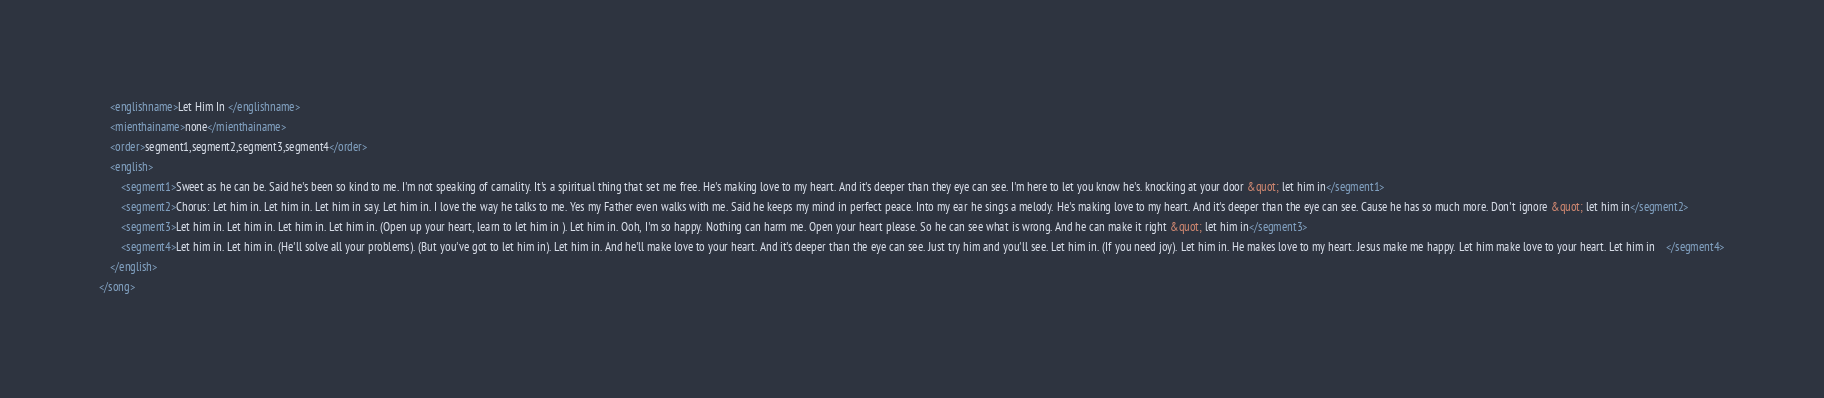<code> <loc_0><loc_0><loc_500><loc_500><_XML_>	<englishname>Let Him In </englishname>
	<mienthainame>none</mienthainame>
	<order>segment1,segment2,segment3,segment4</order>
	<english>
		<segment1>Sweet as he can be. Said he's been so kind to me. I'm not speaking of carnality. It's a spiritual thing that set me free. He's making love to my heart. And it's deeper than they eye can see. I'm here to let you know he's. knocking at your door &quot; let him in</segment1>
		<segment2>Chorus: Let him in. Let him in. Let him in say. Let him in. I love the way he talks to me. Yes my Father even walks with me. Said he keeps my mind in perfect peace. Into my ear he sings a melody. He's making love to my heart. And it's deeper than the eye can see. Cause he has so much more. Don't ignore &quot; let him in</segment2>
		<segment3>Let him in. Let him in. Let him in. Let him in. (Open up your heart, learn to let him in ). Let him in. Ooh, I'm so happy. Nothing can harm me. Open your heart please. So he can see what is wrong. And he can make it right &quot; let him in</segment3>
		<segment4>Let him in. Let him in. (He'll solve all your problems). (But you've got to let him in). Let him in. And he'll make love to your heart. And it's deeper than the eye can see. Just try him and you'll see. Let him in. (If you need joy). Let him in. He makes love to my heart. Jesus make me happy. Let him make love to your heart. Let him in    </segment4>
	</english>
</song>
</code> 